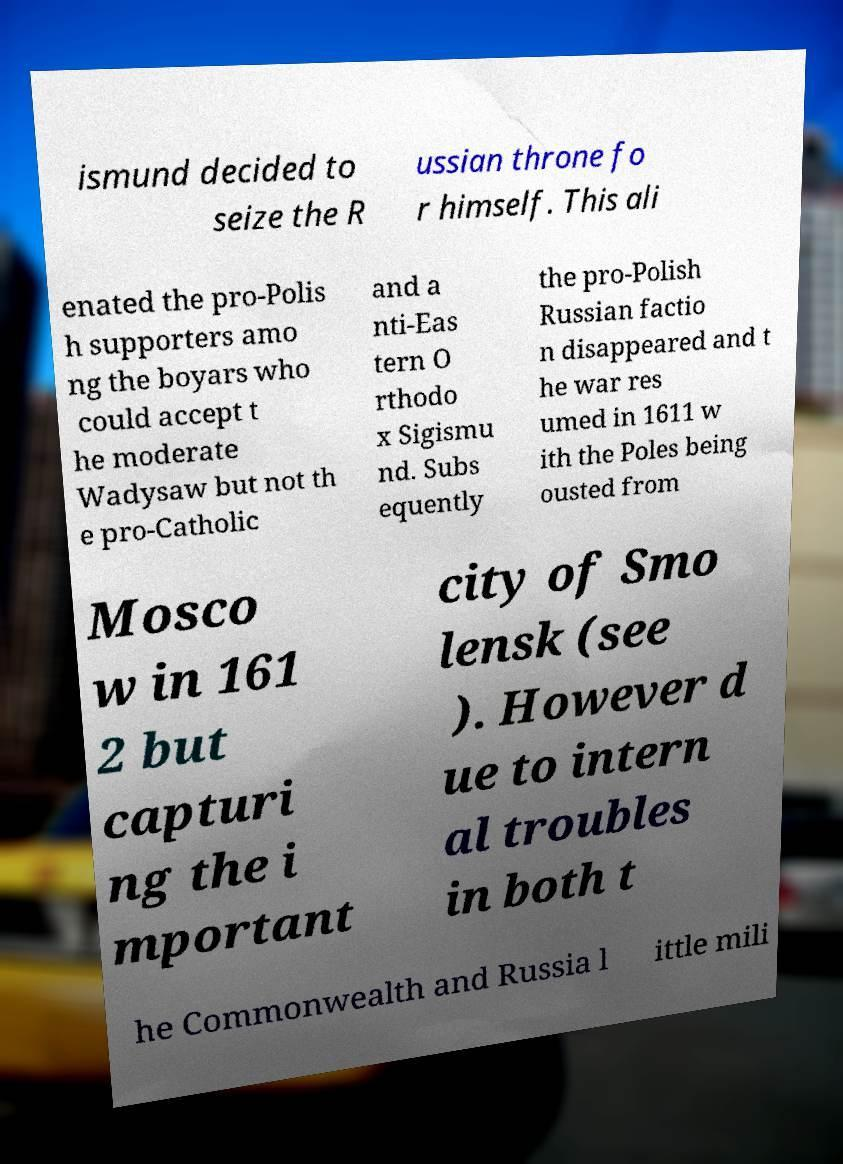Could you assist in decoding the text presented in this image and type it out clearly? ismund decided to seize the R ussian throne fo r himself. This ali enated the pro-Polis h supporters amo ng the boyars who could accept t he moderate Wadysaw but not th e pro-Catholic and a nti-Eas tern O rthodo x Sigismu nd. Subs equently the pro-Polish Russian factio n disappeared and t he war res umed in 1611 w ith the Poles being ousted from Mosco w in 161 2 but capturi ng the i mportant city of Smo lensk (see ). However d ue to intern al troubles in both t he Commonwealth and Russia l ittle mili 